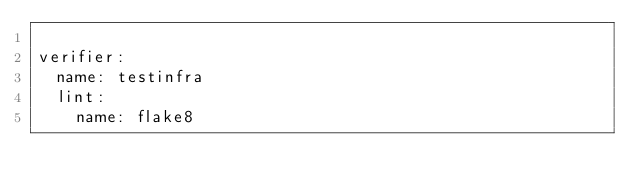<code> <loc_0><loc_0><loc_500><loc_500><_YAML_>
verifier:
  name: testinfra
  lint:
    name: flake8
</code> 